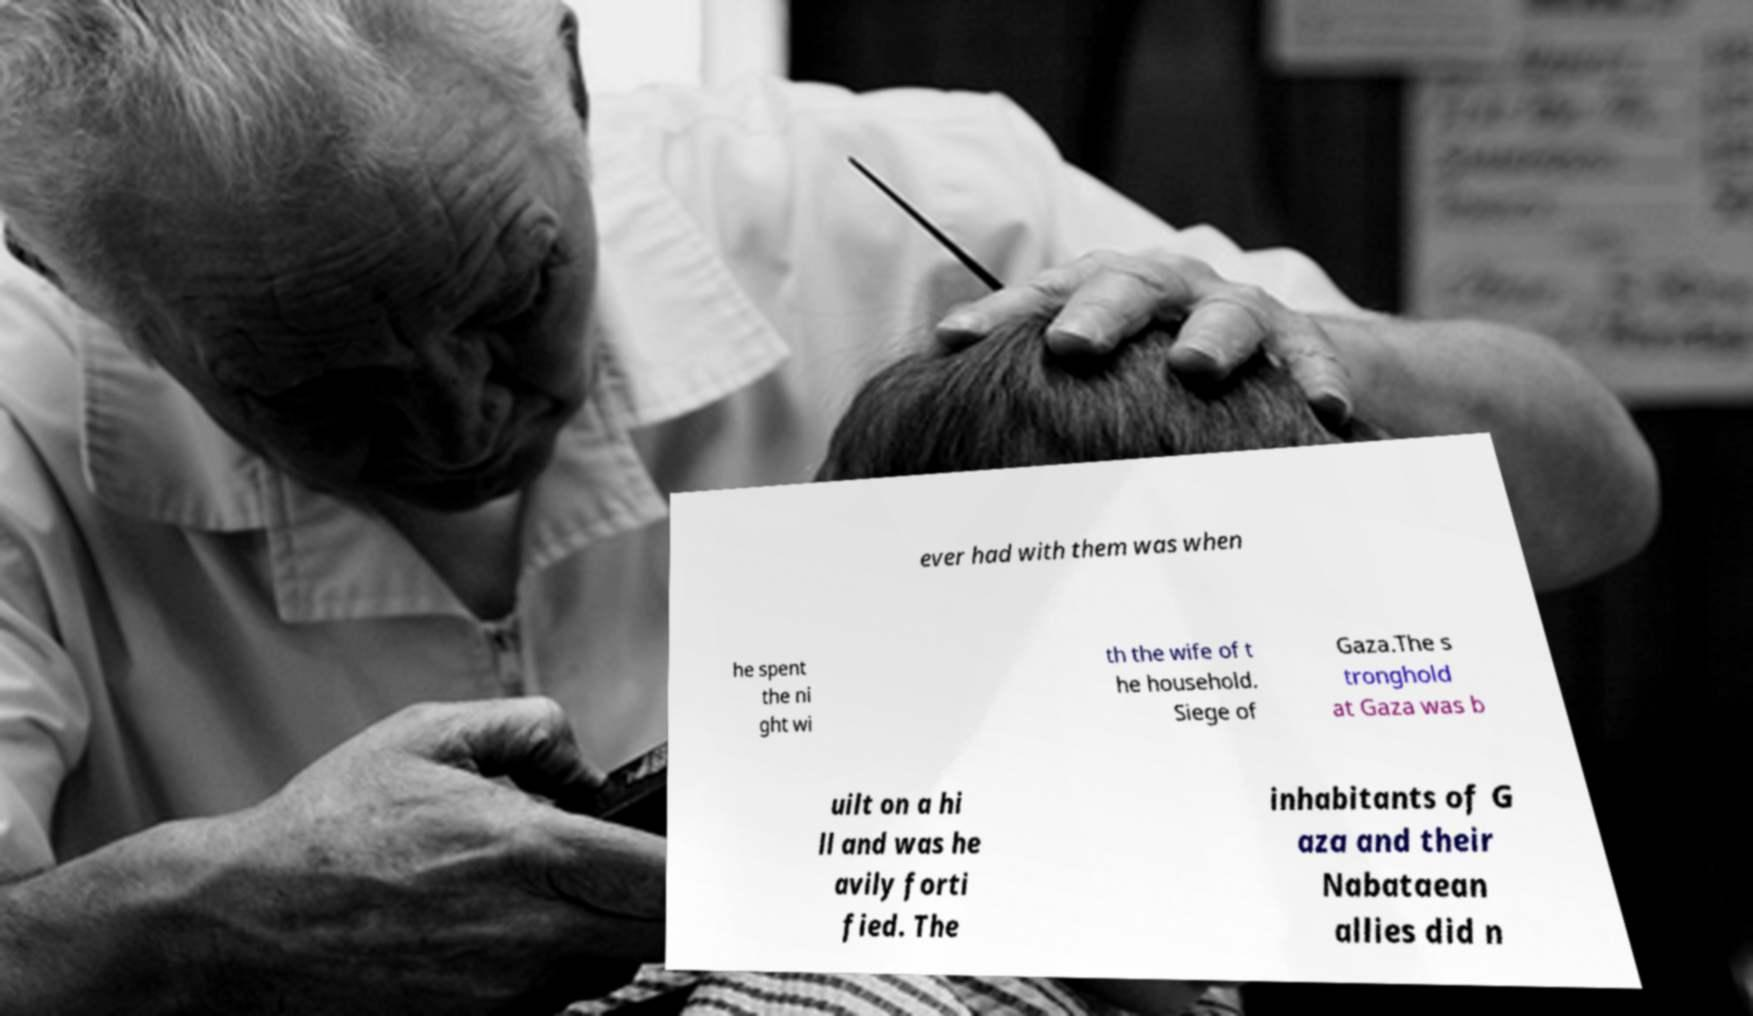For documentation purposes, I need the text within this image transcribed. Could you provide that? ever had with them was when he spent the ni ght wi th the wife of t he household. Siege of Gaza.The s tronghold at Gaza was b uilt on a hi ll and was he avily forti fied. The inhabitants of G aza and their Nabataean allies did n 